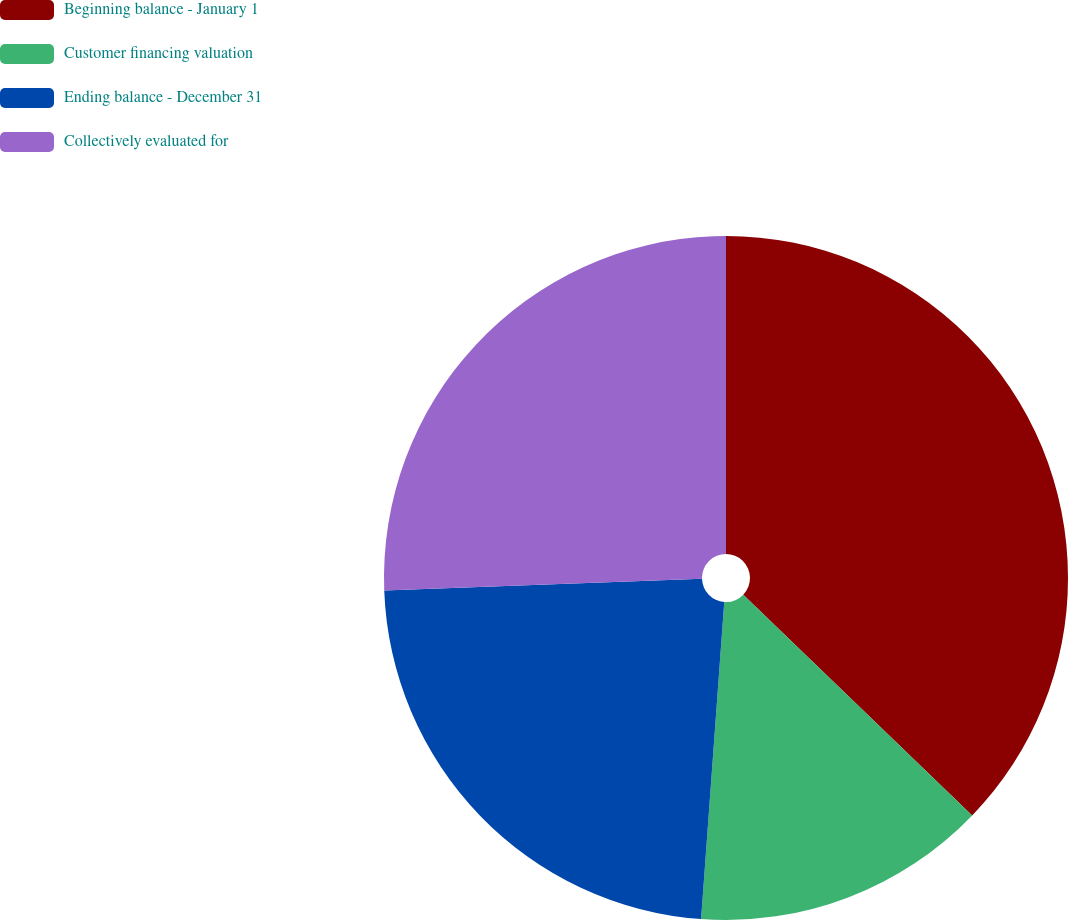<chart> <loc_0><loc_0><loc_500><loc_500><pie_chart><fcel>Beginning balance - January 1<fcel>Customer financing valuation<fcel>Ending balance - December 31<fcel>Collectively evaluated for<nl><fcel>37.21%<fcel>13.95%<fcel>23.26%<fcel>25.58%<nl></chart> 